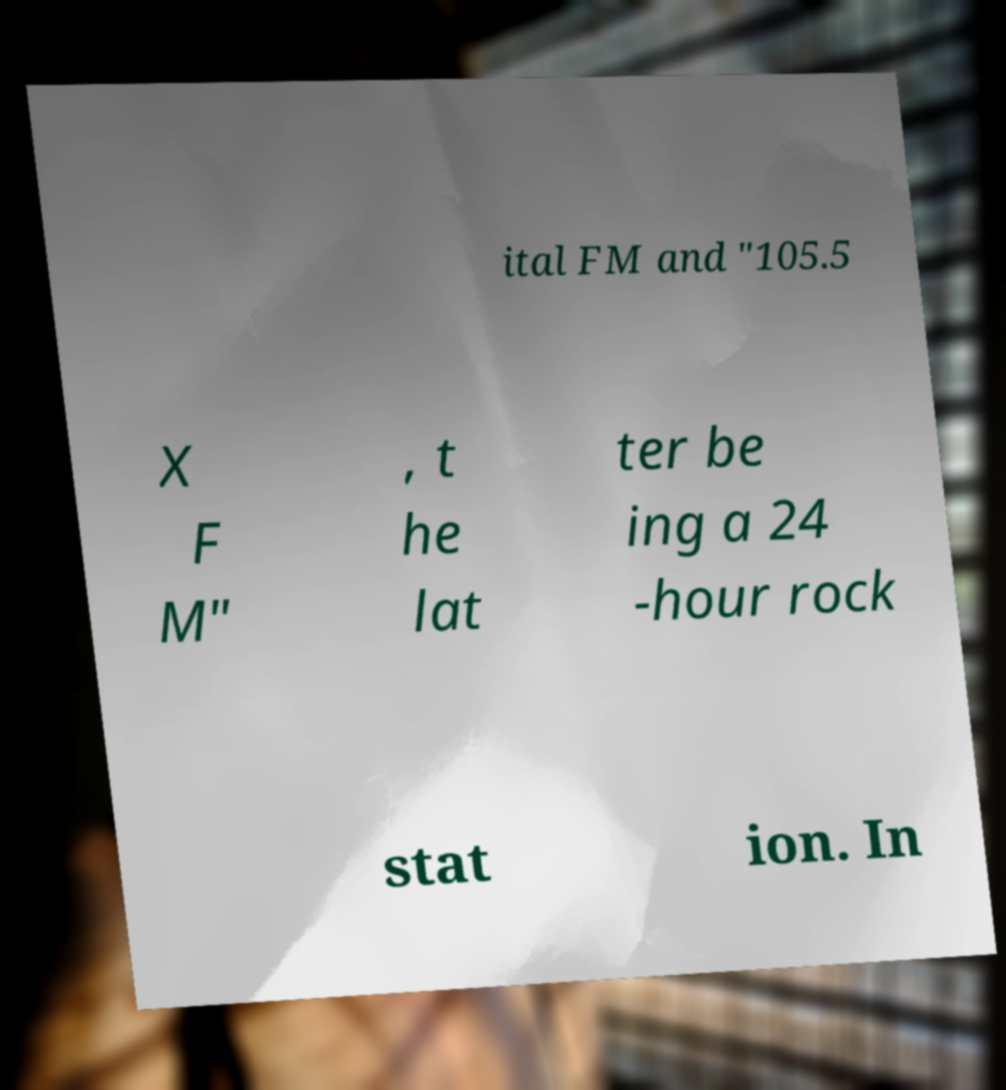Please identify and transcribe the text found in this image. ital FM and "105.5 X F M" , t he lat ter be ing a 24 -hour rock stat ion. In 